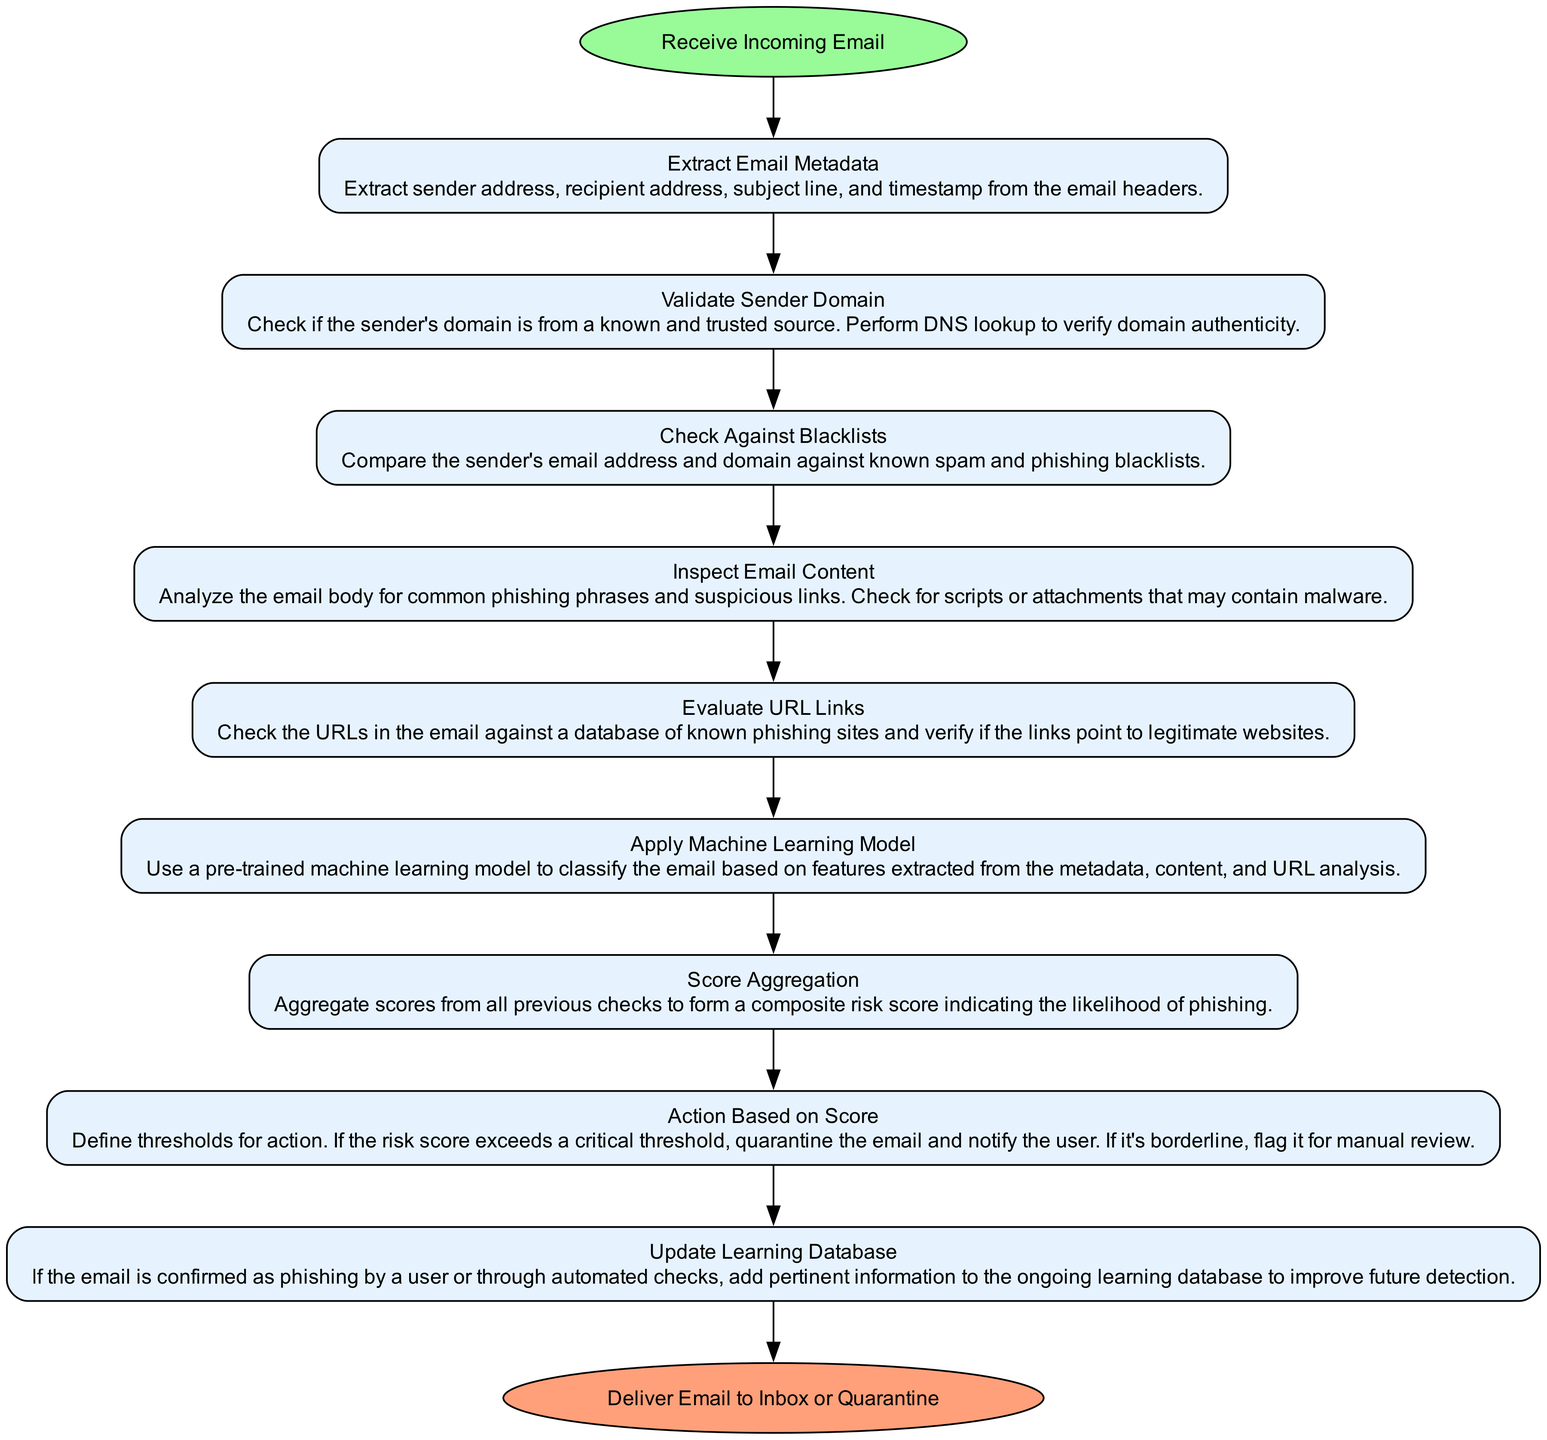What is the starting point of the flowchart? The flowchart starts with the node labeled "Receive Incoming Email", which is the first node that the process flows from.
Answer: Receive Incoming Email How many process nodes are there in total? There are nine process nodes in the flowchart consisting of steps from "Extract Email Metadata" to "Update Learning Database".
Answer: Nine What action is taken if the risk score exceeds the critical threshold? According to the flowchart, if the risk score exceeds the critical threshold, the email is quarantined and the user is notified.
Answer: Quarantine the email and notify the user What is the last step in the flowchart? The last step, indicated in the flowchart, is labeled "Deliver Email to Inbox or Quarantine", which shows the endpoint of the process.
Answer: Deliver Email to Inbox or Quarantine What node follows "Check Against Blacklists"? After "Check Against Blacklists," the next node in the flowchart is "Inspect Email Content", showing the sequential flow from one process to the next.
Answer: Inspect Email Content What is the purpose of "Update Learning Database"? The purpose of "Update Learning Database" is to add pertinent information if the email is confirmed as phishing, which contributes to improving future detection methods.
Answer: Improve future detection Why is "Evaluate URL Links" critical in the protocol? "Evaluate URL Links" is critical because it checks the URLs in the email against known phishing sites, which is essential for preventing access to malicious content.
Answer: Prevent malicious content Which step involves using machine learning? The step titled "Apply Machine Learning Model" specifically involves using a pre-trained model to classify the email, highlighting its importance in the detection protocol.
Answer: Apply Machine Learning Model What does the node "Score Aggregation" collect? "Score Aggregation" collects scores from all previous checks to form a composite risk score, indicating how likely the email is to be phishing.
Answer: Composite risk score 